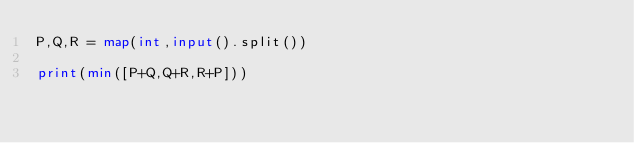<code> <loc_0><loc_0><loc_500><loc_500><_Python_>P,Q,R = map(int,input().split())

print(min([P+Q,Q+R,R+P]))</code> 